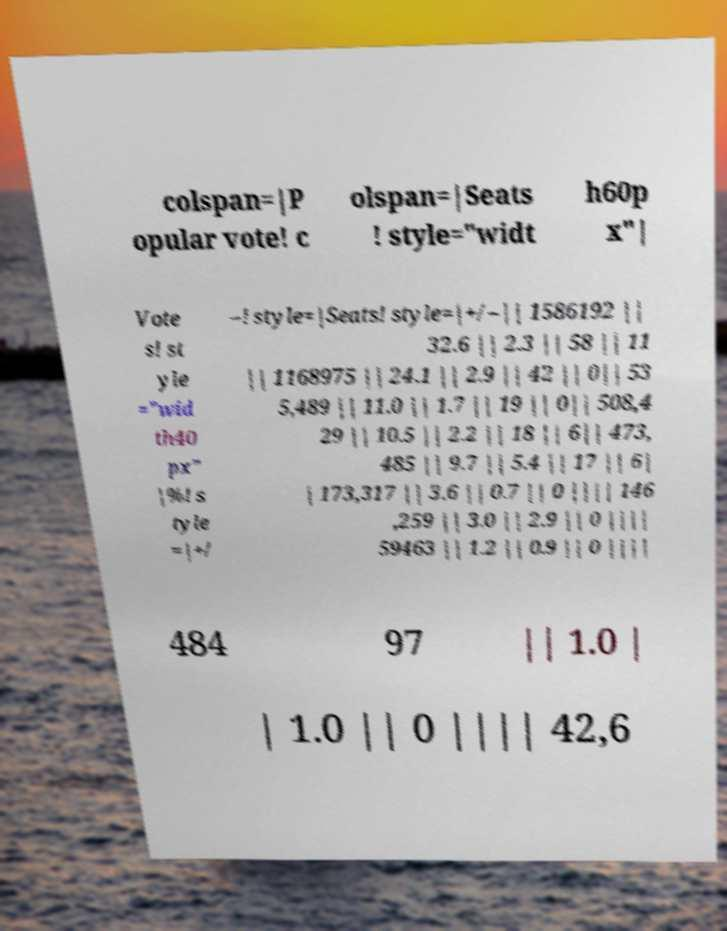Please read and relay the text visible in this image. What does it say? colspan=|P opular vote! c olspan=|Seats ! style="widt h60p x"| Vote s! st yle ="wid th40 px" |%! s tyle =|+/ –! style=|Seats! style=|+/–|| 1586192 || 32.6 || 2.3 || 58 || 11 || 1168975 || 24.1 || 2.9 || 42 || 0|| 53 5,489 || 11.0 || 1.7 || 19 || 0|| 508,4 29 || 10.5 || 2.2 || 18 || 6|| 473, 485 || 9.7 || 5.4 || 17 || 6| | 173,317 || 3.6 || 0.7 || 0 |||| 146 ,259 || 3.0 || 2.9 || 0 |||| 59463 || 1.2 || 0.9 || 0 |||| 484 97 || 1.0 | | 1.0 || 0 |||| 42,6 